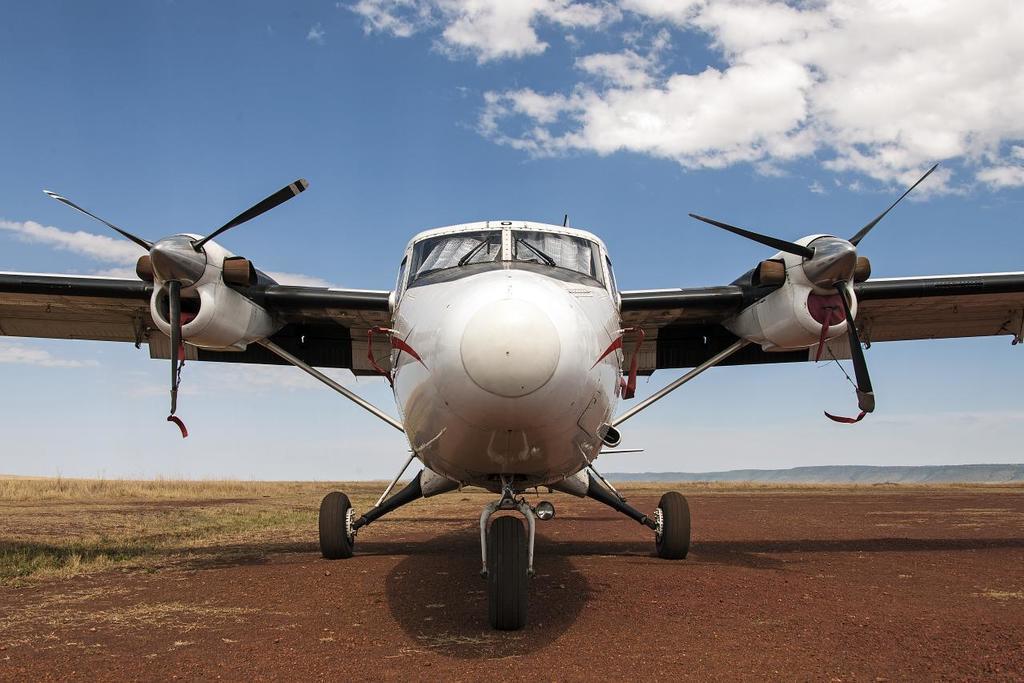In one or two sentences, can you explain what this image depicts? In this image there is an aircraft on the ground. Beside the aircraft there's grass on the ground. In the background there are mountains. At the top there is the sky. 